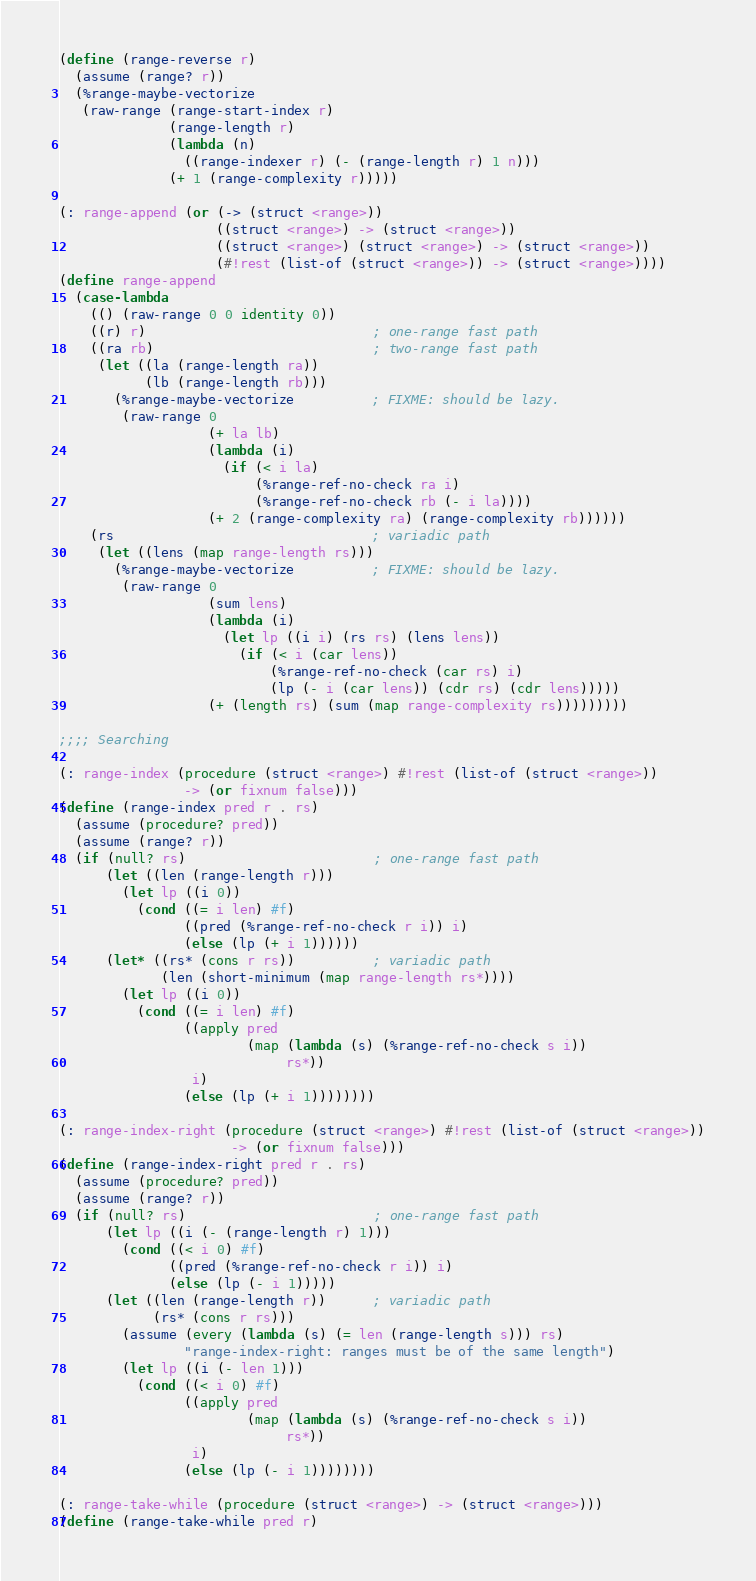Convert code to text. <code><loc_0><loc_0><loc_500><loc_500><_Scheme_>(define (range-reverse r)
  (assume (range? r))
  (%range-maybe-vectorize
   (raw-range (range-start-index r)
              (range-length r)
              (lambda (n)
                ((range-indexer r) (- (range-length r) 1 n)))
              (+ 1 (range-complexity r)))))

(: range-append (or (-> (struct <range>))
                    ((struct <range>) -> (struct <range>))
                    ((struct <range>) (struct <range>) -> (struct <range>))
                    (#!rest (list-of (struct <range>)) -> (struct <range>))))
(define range-append
  (case-lambda
    (() (raw-range 0 0 identity 0))
    ((r) r)                             ; one-range fast path
    ((ra rb)                            ; two-range fast path
     (let ((la (range-length ra))
           (lb (range-length rb)))
       (%range-maybe-vectorize          ; FIXME: should be lazy.
        (raw-range 0
                   (+ la lb)
                   (lambda (i)
                     (if (< i la)
                         (%range-ref-no-check ra i)
                         (%range-ref-no-check rb (- i la))))
                   (+ 2 (range-complexity ra) (range-complexity rb))))))
    (rs                                 ; variadic path
     (let ((lens (map range-length rs)))
       (%range-maybe-vectorize          ; FIXME: should be lazy.
        (raw-range 0
                   (sum lens)
                   (lambda (i)
                     (let lp ((i i) (rs rs) (lens lens))
                       (if (< i (car lens))
                           (%range-ref-no-check (car rs) i)
                           (lp (- i (car lens)) (cdr rs) (cdr lens)))))
                   (+ (length rs) (sum (map range-complexity rs)))))))))

;;;; Searching

(: range-index (procedure (struct <range>) #!rest (list-of (struct <range>))
                -> (or fixnum false)))
(define (range-index pred r . rs)
  (assume (procedure? pred))
  (assume (range? r))
  (if (null? rs)                        ; one-range fast path
      (let ((len (range-length r)))
        (let lp ((i 0))
          (cond ((= i len) #f)
                ((pred (%range-ref-no-check r i)) i)
                (else (lp (+ i 1))))))
      (let* ((rs* (cons r rs))          ; variadic path
             (len (short-minimum (map range-length rs*))))
        (let lp ((i 0))
          (cond ((= i len) #f)
                ((apply pred
                        (map (lambda (s) (%range-ref-no-check s i))
                             rs*))
                 i)
                (else (lp (+ i 1))))))))

(: range-index-right (procedure (struct <range>) #!rest (list-of (struct <range>))
                      -> (or fixnum false)))
(define (range-index-right pred r . rs)
  (assume (procedure? pred))
  (assume (range? r))
  (if (null? rs)                        ; one-range fast path
      (let lp ((i (- (range-length r) 1)))
        (cond ((< i 0) #f)
              ((pred (%range-ref-no-check r i)) i)
              (else (lp (- i 1)))))
      (let ((len (range-length r))      ; variadic path
            (rs* (cons r rs)))
        (assume (every (lambda (s) (= len (range-length s))) rs)
                "range-index-right: ranges must be of the same length")
        (let lp ((i (- len 1)))
          (cond ((< i 0) #f)
                ((apply pred
                        (map (lambda (s) (%range-ref-no-check s i))
                             rs*))
                 i)
                (else (lp (- i 1))))))))

(: range-take-while (procedure (struct <range>) -> (struct <range>)))
(define (range-take-while pred r)</code> 